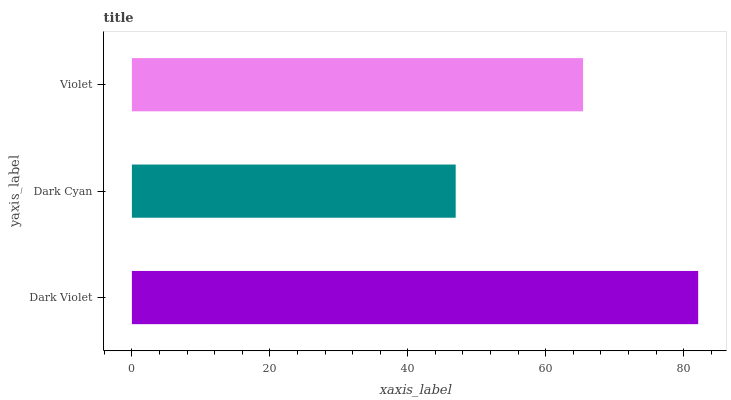Is Dark Cyan the minimum?
Answer yes or no. Yes. Is Dark Violet the maximum?
Answer yes or no. Yes. Is Violet the minimum?
Answer yes or no. No. Is Violet the maximum?
Answer yes or no. No. Is Violet greater than Dark Cyan?
Answer yes or no. Yes. Is Dark Cyan less than Violet?
Answer yes or no. Yes. Is Dark Cyan greater than Violet?
Answer yes or no. No. Is Violet less than Dark Cyan?
Answer yes or no. No. Is Violet the high median?
Answer yes or no. Yes. Is Violet the low median?
Answer yes or no. Yes. Is Dark Cyan the high median?
Answer yes or no. No. Is Dark Violet the low median?
Answer yes or no. No. 